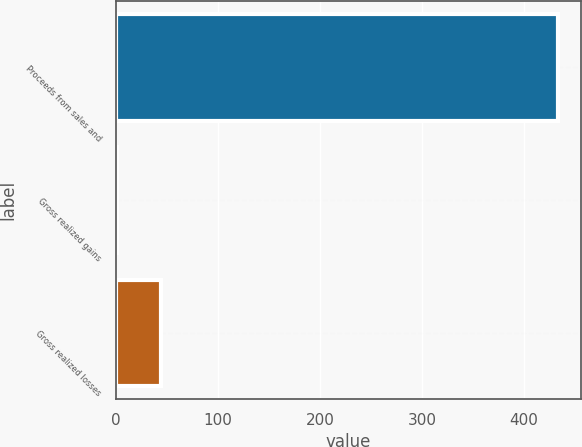Convert chart to OTSL. <chart><loc_0><loc_0><loc_500><loc_500><bar_chart><fcel>Proceeds from sales and<fcel>Gross realized gains<fcel>Gross realized losses<nl><fcel>433.9<fcel>1.3<fcel>44.56<nl></chart> 